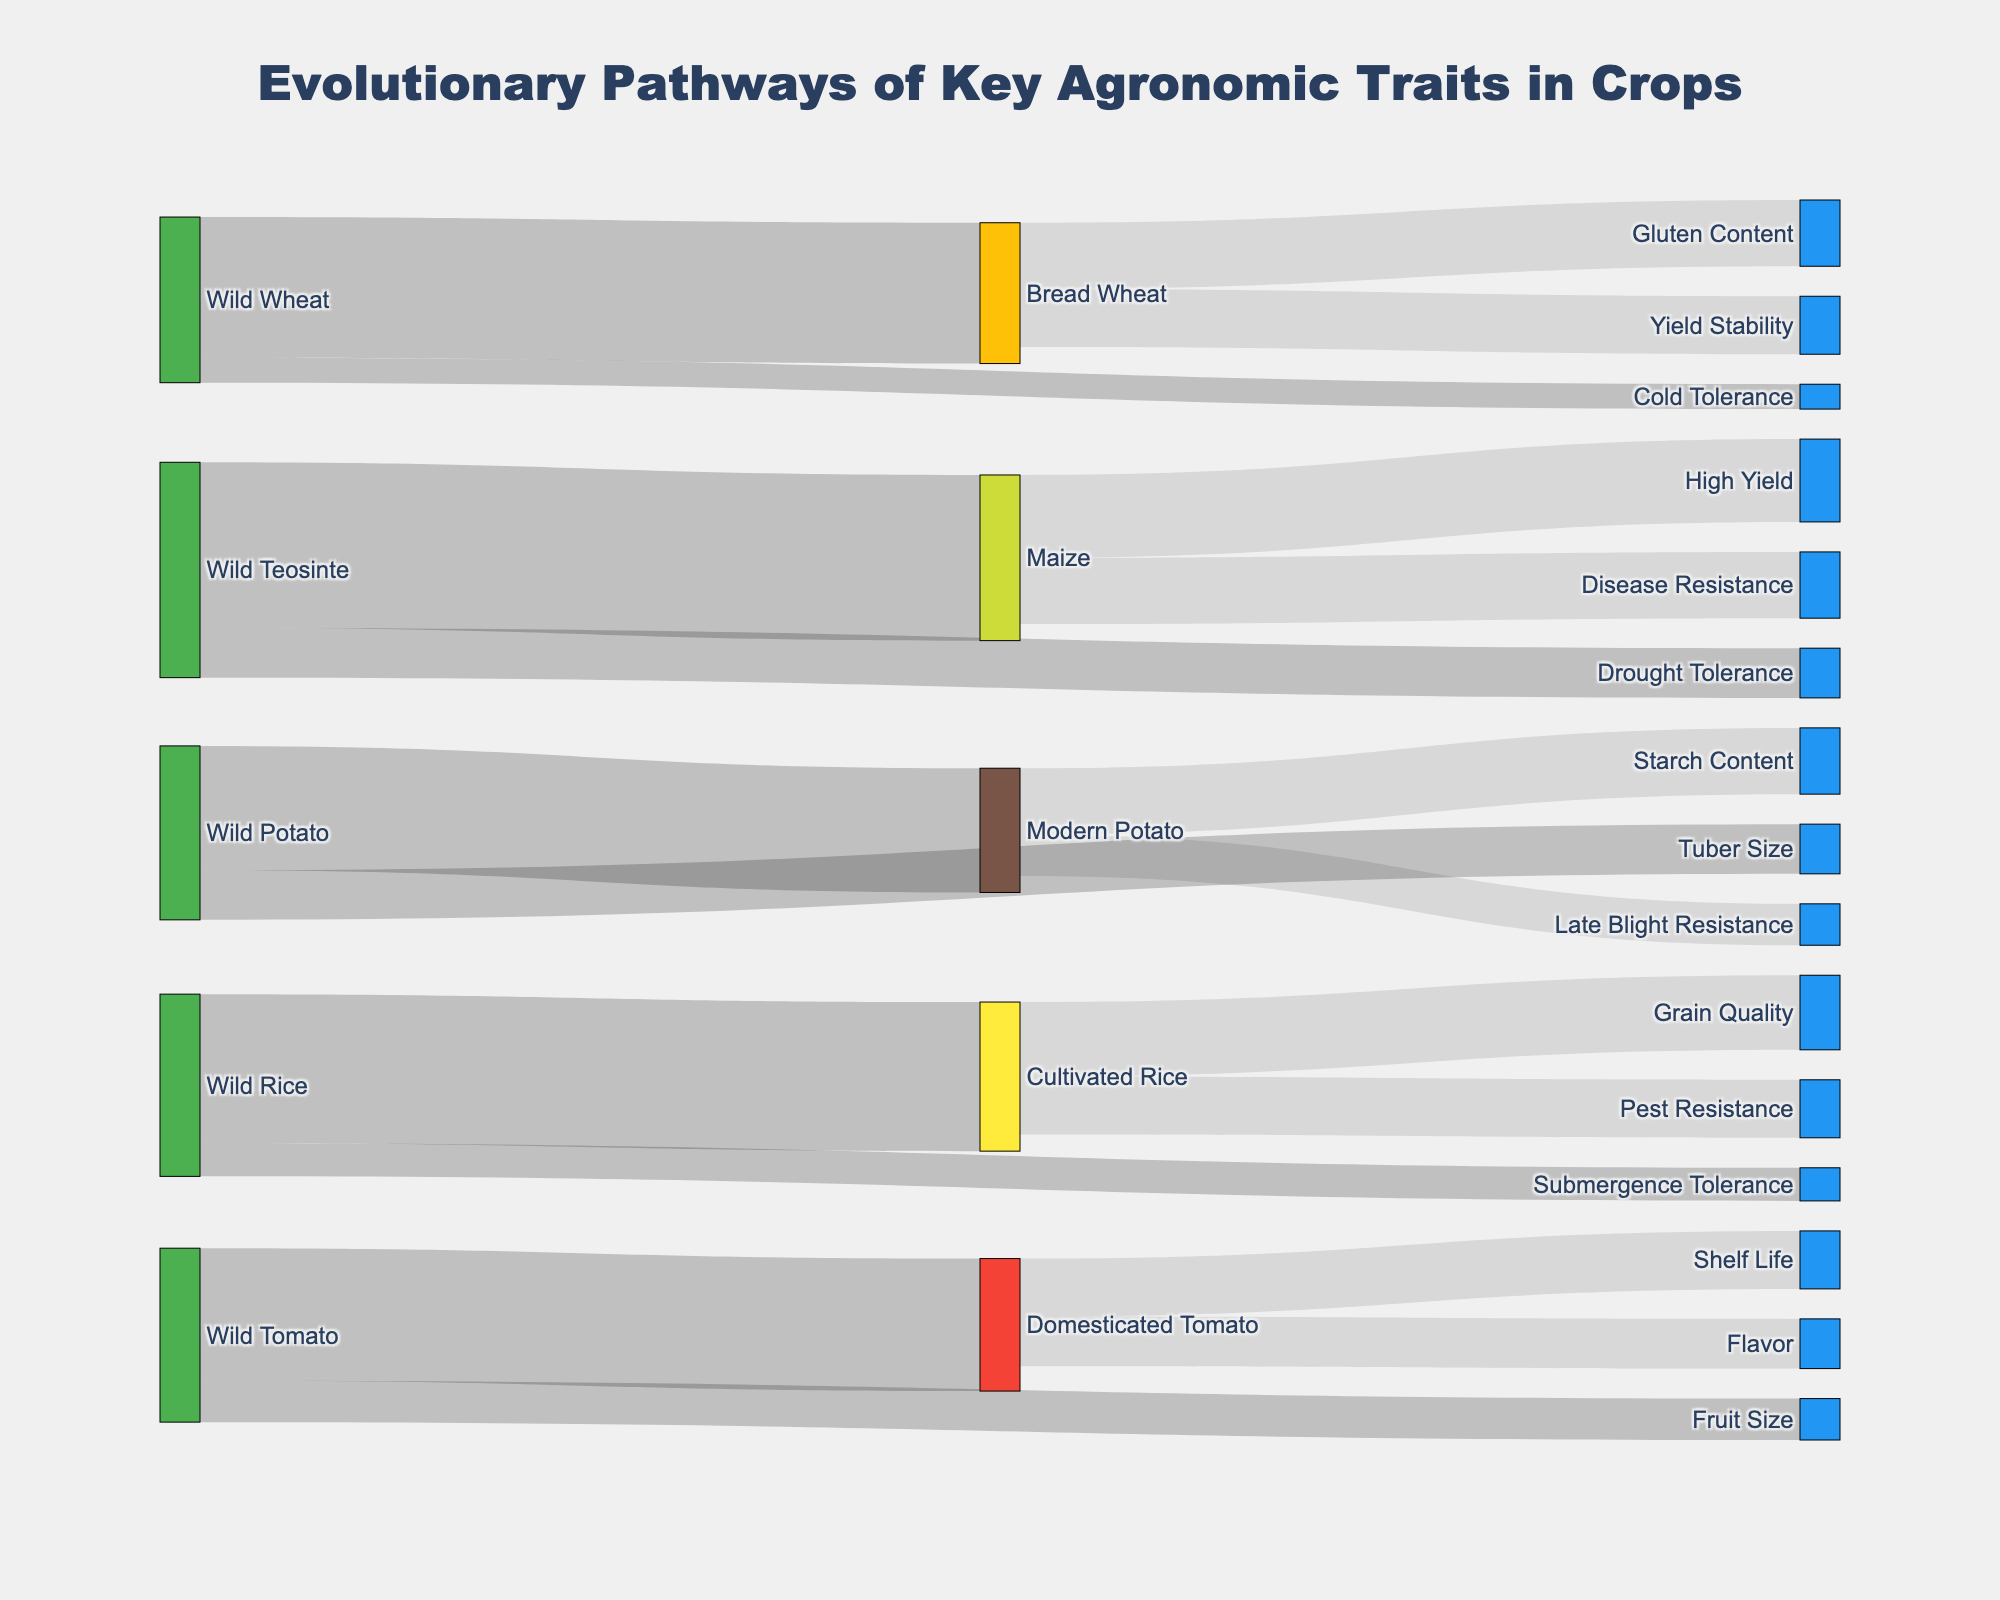What is the title of the figure? The title is visibly placed at the top center of the figure within the layout. It represents the general theme of the Sankey diagram.
Answer: Evolutionary Pathways of Key Agronomic Traits in Crops What color represents the wild type nodes in the diagram? By observing the node color scheme, it can be inferred what color is used specifically for wild type origins compared to domesticated or cultivated nodes.
Answer: Green Which crop trait has the highest value in Maize? Examine the Maize nodes and associated target nodes to determine which target has the highest value in the figure. Maize connects to High Yield and Disease Resistance with different values.
Answer: High Yield How many pathways emerge from Wild Tomato? Look at the figure and count the number of links originating from the Wild Tomato node toward other nodes.
Answer: 2 What is the total value summed from Wild Teosinte to its targets? Sum the values of all pathways emerging from the Wild Teosinte node to its targets: Maize and Drought Tolerance.
Answer: 130 Which domesticated crop has the lower shelf life trait value, Tomato or Potato? Compare the trait values related to shelf life emerging from the Domesticated Tomato and any similar trait pathways for Potato in the figure.
Answer: Tomato How does the color coding help distinguish between wild type and cultivated nodes? Observe the color differences assigned to wild and cultivated nodes and deduce how these colors help in differentiating between the two categories, which helps readability.
Answer: Green for wild type, orange and other colors for cultivated/domesticated Which crop has more pathways leading to resistance traits: Maize, Rice, or Potato? Identify each crop and count the pathways leading to any resistance-related traits, including pest, disease, or other resistances. Maize, Rice, and Potato all have resistance pathways, but their count differs.
Answer: Maize What is the cumulative value of all traits emerging from Bread Wheat? Sum the values of all pathways emerging from the Bread Wheat node to its distinct traits: Gluten Content and Yield Stability.
Answer: 75 Which crop has traits leading to cold or drought tolerance? Identify which nodes contain pathways leading to cold tolerance and drought tolerance traits from Maize, Rice, Potato, and Wheat crops.
Answer: Maize and Wheat 